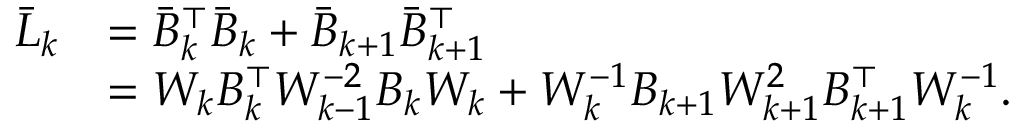<formula> <loc_0><loc_0><loc_500><loc_500>\begin{array} { r l } { \bar { L } _ { k } } & { = \bar { B } _ { k } ^ { \top } \bar { B } _ { k } + \bar { B } _ { k + 1 } \bar { B } _ { k + 1 } ^ { \top } } \\ & { = W _ { k } B _ { k } ^ { \top } W _ { k - 1 } ^ { - 2 } B _ { k } W _ { k } + W _ { k } ^ { - 1 } B _ { k + 1 } W _ { k + 1 } ^ { 2 } B _ { k + 1 } ^ { \top } W _ { k } ^ { - 1 } . } \end{array}</formula> 